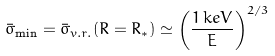Convert formula to latex. <formula><loc_0><loc_0><loc_500><loc_500>\bar { \sigma } _ { \min } = \bar { \sigma } _ { v . r . } ( R = R _ { * } ) \simeq \left ( \frac { 1 \, k e V } { E } \right ) ^ { 2 / 3 } \</formula> 